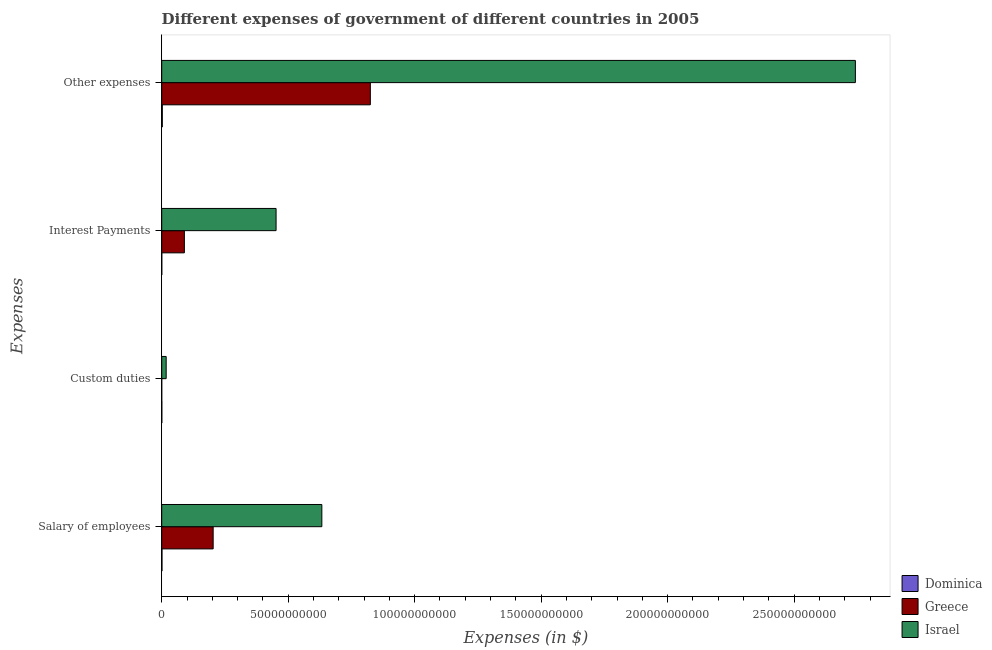How many different coloured bars are there?
Your response must be concise. 3. How many groups of bars are there?
Offer a very short reply. 4. Are the number of bars per tick equal to the number of legend labels?
Your response must be concise. Yes. Are the number of bars on each tick of the Y-axis equal?
Give a very brief answer. Yes. What is the label of the 2nd group of bars from the top?
Make the answer very short. Interest Payments. What is the amount spent on interest payments in Greece?
Your answer should be compact. 8.96e+09. Across all countries, what is the maximum amount spent on salary of employees?
Make the answer very short. 6.33e+1. Across all countries, what is the minimum amount spent on interest payments?
Provide a succinct answer. 2.59e+07. In which country was the amount spent on salary of employees minimum?
Offer a terse response. Dominica. What is the total amount spent on salary of employees in the graph?
Provide a short and direct response. 8.37e+1. What is the difference between the amount spent on custom duties in Dominica and that in Greece?
Offer a terse response. 3.74e+07. What is the difference between the amount spent on interest payments in Dominica and the amount spent on salary of employees in Greece?
Offer a terse response. -2.03e+1. What is the average amount spent on custom duties per country?
Offer a terse response. 6.01e+08. What is the difference between the amount spent on other expenses and amount spent on custom duties in Greece?
Your answer should be very brief. 8.25e+1. In how many countries, is the amount spent on salary of employees greater than 50000000000 $?
Your response must be concise. 1. What is the ratio of the amount spent on custom duties in Greece to that in Israel?
Keep it short and to the point. 0. Is the amount spent on other expenses in Israel less than that in Greece?
Provide a short and direct response. No. What is the difference between the highest and the second highest amount spent on other expenses?
Make the answer very short. 1.92e+11. What is the difference between the highest and the lowest amount spent on salary of employees?
Provide a succinct answer. 6.32e+1. In how many countries, is the amount spent on other expenses greater than the average amount spent on other expenses taken over all countries?
Give a very brief answer. 1. What does the 1st bar from the bottom in Salary of employees represents?
Offer a very short reply. Dominica. Is it the case that in every country, the sum of the amount spent on salary of employees and amount spent on custom duties is greater than the amount spent on interest payments?
Your answer should be very brief. Yes. Are all the bars in the graph horizontal?
Provide a succinct answer. Yes. What is the difference between two consecutive major ticks on the X-axis?
Provide a succinct answer. 5.00e+1. Does the graph contain any zero values?
Offer a very short reply. No. What is the title of the graph?
Your response must be concise. Different expenses of government of different countries in 2005. Does "Heavily indebted poor countries" appear as one of the legend labels in the graph?
Offer a terse response. No. What is the label or title of the X-axis?
Keep it short and to the point. Expenses (in $). What is the label or title of the Y-axis?
Your answer should be very brief. Expenses. What is the Expenses (in $) in Dominica in Salary of employees?
Provide a succinct answer. 1.08e+08. What is the Expenses (in $) in Greece in Salary of employees?
Provide a succinct answer. 2.03e+1. What is the Expenses (in $) of Israel in Salary of employees?
Offer a terse response. 6.33e+1. What is the Expenses (in $) in Dominica in Custom duties?
Your answer should be compact. 4.04e+07. What is the Expenses (in $) of Israel in Custom duties?
Provide a short and direct response. 1.76e+09. What is the Expenses (in $) in Dominica in Interest Payments?
Ensure brevity in your answer.  2.59e+07. What is the Expenses (in $) in Greece in Interest Payments?
Keep it short and to the point. 8.96e+09. What is the Expenses (in $) of Israel in Interest Payments?
Ensure brevity in your answer.  4.52e+1. What is the Expenses (in $) of Dominica in Other expenses?
Your response must be concise. 2.37e+08. What is the Expenses (in $) of Greece in Other expenses?
Make the answer very short. 8.25e+1. What is the Expenses (in $) of Israel in Other expenses?
Your answer should be very brief. 2.74e+11. Across all Expenses, what is the maximum Expenses (in $) of Dominica?
Provide a succinct answer. 2.37e+08. Across all Expenses, what is the maximum Expenses (in $) in Greece?
Provide a short and direct response. 8.25e+1. Across all Expenses, what is the maximum Expenses (in $) in Israel?
Ensure brevity in your answer.  2.74e+11. Across all Expenses, what is the minimum Expenses (in $) of Dominica?
Your answer should be very brief. 2.59e+07. Across all Expenses, what is the minimum Expenses (in $) in Israel?
Your answer should be very brief. 1.76e+09. What is the total Expenses (in $) in Dominica in the graph?
Provide a short and direct response. 4.12e+08. What is the total Expenses (in $) in Greece in the graph?
Provide a succinct answer. 1.12e+11. What is the total Expenses (in $) in Israel in the graph?
Keep it short and to the point. 3.84e+11. What is the difference between the Expenses (in $) in Dominica in Salary of employees and that in Custom duties?
Your answer should be very brief. 6.81e+07. What is the difference between the Expenses (in $) in Greece in Salary of employees and that in Custom duties?
Ensure brevity in your answer.  2.03e+1. What is the difference between the Expenses (in $) of Israel in Salary of employees and that in Custom duties?
Your answer should be compact. 6.15e+1. What is the difference between the Expenses (in $) of Dominica in Salary of employees and that in Interest Payments?
Keep it short and to the point. 8.26e+07. What is the difference between the Expenses (in $) of Greece in Salary of employees and that in Interest Payments?
Keep it short and to the point. 1.14e+1. What is the difference between the Expenses (in $) in Israel in Salary of employees and that in Interest Payments?
Make the answer very short. 1.81e+1. What is the difference between the Expenses (in $) of Dominica in Salary of employees and that in Other expenses?
Give a very brief answer. -1.29e+08. What is the difference between the Expenses (in $) of Greece in Salary of employees and that in Other expenses?
Make the answer very short. -6.21e+1. What is the difference between the Expenses (in $) in Israel in Salary of employees and that in Other expenses?
Keep it short and to the point. -2.11e+11. What is the difference between the Expenses (in $) of Dominica in Custom duties and that in Interest Payments?
Keep it short and to the point. 1.45e+07. What is the difference between the Expenses (in $) of Greece in Custom duties and that in Interest Payments?
Your answer should be compact. -8.96e+09. What is the difference between the Expenses (in $) in Israel in Custom duties and that in Interest Payments?
Your response must be concise. -4.35e+1. What is the difference between the Expenses (in $) of Dominica in Custom duties and that in Other expenses?
Make the answer very short. -1.97e+08. What is the difference between the Expenses (in $) of Greece in Custom duties and that in Other expenses?
Provide a succinct answer. -8.25e+1. What is the difference between the Expenses (in $) in Israel in Custom duties and that in Other expenses?
Ensure brevity in your answer.  -2.72e+11. What is the difference between the Expenses (in $) in Dominica in Interest Payments and that in Other expenses?
Keep it short and to the point. -2.12e+08. What is the difference between the Expenses (in $) in Greece in Interest Payments and that in Other expenses?
Your response must be concise. -7.35e+1. What is the difference between the Expenses (in $) in Israel in Interest Payments and that in Other expenses?
Make the answer very short. -2.29e+11. What is the difference between the Expenses (in $) of Dominica in Salary of employees and the Expenses (in $) of Greece in Custom duties?
Offer a terse response. 1.06e+08. What is the difference between the Expenses (in $) of Dominica in Salary of employees and the Expenses (in $) of Israel in Custom duties?
Your answer should be compact. -1.65e+09. What is the difference between the Expenses (in $) of Greece in Salary of employees and the Expenses (in $) of Israel in Custom duties?
Give a very brief answer. 1.86e+1. What is the difference between the Expenses (in $) in Dominica in Salary of employees and the Expenses (in $) in Greece in Interest Payments?
Keep it short and to the point. -8.85e+09. What is the difference between the Expenses (in $) of Dominica in Salary of employees and the Expenses (in $) of Israel in Interest Payments?
Give a very brief answer. -4.51e+1. What is the difference between the Expenses (in $) of Greece in Salary of employees and the Expenses (in $) of Israel in Interest Payments?
Your response must be concise. -2.49e+1. What is the difference between the Expenses (in $) of Dominica in Salary of employees and the Expenses (in $) of Greece in Other expenses?
Ensure brevity in your answer.  -8.24e+1. What is the difference between the Expenses (in $) in Dominica in Salary of employees and the Expenses (in $) in Israel in Other expenses?
Make the answer very short. -2.74e+11. What is the difference between the Expenses (in $) of Greece in Salary of employees and the Expenses (in $) of Israel in Other expenses?
Offer a very short reply. -2.54e+11. What is the difference between the Expenses (in $) in Dominica in Custom duties and the Expenses (in $) in Greece in Interest Payments?
Ensure brevity in your answer.  -8.92e+09. What is the difference between the Expenses (in $) of Dominica in Custom duties and the Expenses (in $) of Israel in Interest Payments?
Ensure brevity in your answer.  -4.52e+1. What is the difference between the Expenses (in $) of Greece in Custom duties and the Expenses (in $) of Israel in Interest Payments?
Offer a terse response. -4.52e+1. What is the difference between the Expenses (in $) in Dominica in Custom duties and the Expenses (in $) in Greece in Other expenses?
Your answer should be very brief. -8.24e+1. What is the difference between the Expenses (in $) in Dominica in Custom duties and the Expenses (in $) in Israel in Other expenses?
Provide a succinct answer. -2.74e+11. What is the difference between the Expenses (in $) in Greece in Custom duties and the Expenses (in $) in Israel in Other expenses?
Provide a short and direct response. -2.74e+11. What is the difference between the Expenses (in $) in Dominica in Interest Payments and the Expenses (in $) in Greece in Other expenses?
Offer a very short reply. -8.24e+1. What is the difference between the Expenses (in $) of Dominica in Interest Payments and the Expenses (in $) of Israel in Other expenses?
Offer a very short reply. -2.74e+11. What is the difference between the Expenses (in $) in Greece in Interest Payments and the Expenses (in $) in Israel in Other expenses?
Keep it short and to the point. -2.65e+11. What is the average Expenses (in $) of Dominica per Expenses?
Offer a very short reply. 1.03e+08. What is the average Expenses (in $) in Greece per Expenses?
Provide a succinct answer. 2.79e+1. What is the average Expenses (in $) in Israel per Expenses?
Ensure brevity in your answer.  9.61e+1. What is the difference between the Expenses (in $) in Dominica and Expenses (in $) in Greece in Salary of employees?
Offer a very short reply. -2.02e+1. What is the difference between the Expenses (in $) of Dominica and Expenses (in $) of Israel in Salary of employees?
Keep it short and to the point. -6.32e+1. What is the difference between the Expenses (in $) of Greece and Expenses (in $) of Israel in Salary of employees?
Your response must be concise. -4.30e+1. What is the difference between the Expenses (in $) of Dominica and Expenses (in $) of Greece in Custom duties?
Give a very brief answer. 3.74e+07. What is the difference between the Expenses (in $) of Dominica and Expenses (in $) of Israel in Custom duties?
Your answer should be very brief. -1.72e+09. What is the difference between the Expenses (in $) in Greece and Expenses (in $) in Israel in Custom duties?
Make the answer very short. -1.76e+09. What is the difference between the Expenses (in $) in Dominica and Expenses (in $) in Greece in Interest Payments?
Provide a short and direct response. -8.94e+09. What is the difference between the Expenses (in $) in Dominica and Expenses (in $) in Israel in Interest Payments?
Give a very brief answer. -4.52e+1. What is the difference between the Expenses (in $) of Greece and Expenses (in $) of Israel in Interest Payments?
Your response must be concise. -3.63e+1. What is the difference between the Expenses (in $) of Dominica and Expenses (in $) of Greece in Other expenses?
Provide a short and direct response. -8.22e+1. What is the difference between the Expenses (in $) of Dominica and Expenses (in $) of Israel in Other expenses?
Make the answer very short. -2.74e+11. What is the difference between the Expenses (in $) in Greece and Expenses (in $) in Israel in Other expenses?
Offer a terse response. -1.92e+11. What is the ratio of the Expenses (in $) of Dominica in Salary of employees to that in Custom duties?
Keep it short and to the point. 2.69. What is the ratio of the Expenses (in $) of Greece in Salary of employees to that in Custom duties?
Offer a very short reply. 6778.67. What is the ratio of the Expenses (in $) in Israel in Salary of employees to that in Custom duties?
Give a very brief answer. 35.95. What is the ratio of the Expenses (in $) in Dominica in Salary of employees to that in Interest Payments?
Give a very brief answer. 4.19. What is the ratio of the Expenses (in $) of Greece in Salary of employees to that in Interest Payments?
Provide a succinct answer. 2.27. What is the ratio of the Expenses (in $) of Israel in Salary of employees to that in Interest Payments?
Provide a short and direct response. 1.4. What is the ratio of the Expenses (in $) of Dominica in Salary of employees to that in Other expenses?
Provide a succinct answer. 0.46. What is the ratio of the Expenses (in $) of Greece in Salary of employees to that in Other expenses?
Your answer should be very brief. 0.25. What is the ratio of the Expenses (in $) of Israel in Salary of employees to that in Other expenses?
Keep it short and to the point. 0.23. What is the ratio of the Expenses (in $) of Dominica in Custom duties to that in Interest Payments?
Ensure brevity in your answer.  1.56. What is the ratio of the Expenses (in $) in Greece in Custom duties to that in Interest Payments?
Provide a short and direct response. 0. What is the ratio of the Expenses (in $) in Israel in Custom duties to that in Interest Payments?
Keep it short and to the point. 0.04. What is the ratio of the Expenses (in $) in Dominica in Custom duties to that in Other expenses?
Your response must be concise. 0.17. What is the ratio of the Expenses (in $) in Greece in Custom duties to that in Other expenses?
Provide a short and direct response. 0. What is the ratio of the Expenses (in $) in Israel in Custom duties to that in Other expenses?
Ensure brevity in your answer.  0.01. What is the ratio of the Expenses (in $) in Dominica in Interest Payments to that in Other expenses?
Provide a short and direct response. 0.11. What is the ratio of the Expenses (in $) of Greece in Interest Payments to that in Other expenses?
Give a very brief answer. 0.11. What is the ratio of the Expenses (in $) of Israel in Interest Payments to that in Other expenses?
Make the answer very short. 0.16. What is the difference between the highest and the second highest Expenses (in $) in Dominica?
Make the answer very short. 1.29e+08. What is the difference between the highest and the second highest Expenses (in $) of Greece?
Ensure brevity in your answer.  6.21e+1. What is the difference between the highest and the second highest Expenses (in $) of Israel?
Your response must be concise. 2.11e+11. What is the difference between the highest and the lowest Expenses (in $) in Dominica?
Your answer should be very brief. 2.12e+08. What is the difference between the highest and the lowest Expenses (in $) of Greece?
Offer a very short reply. 8.25e+1. What is the difference between the highest and the lowest Expenses (in $) in Israel?
Provide a short and direct response. 2.72e+11. 